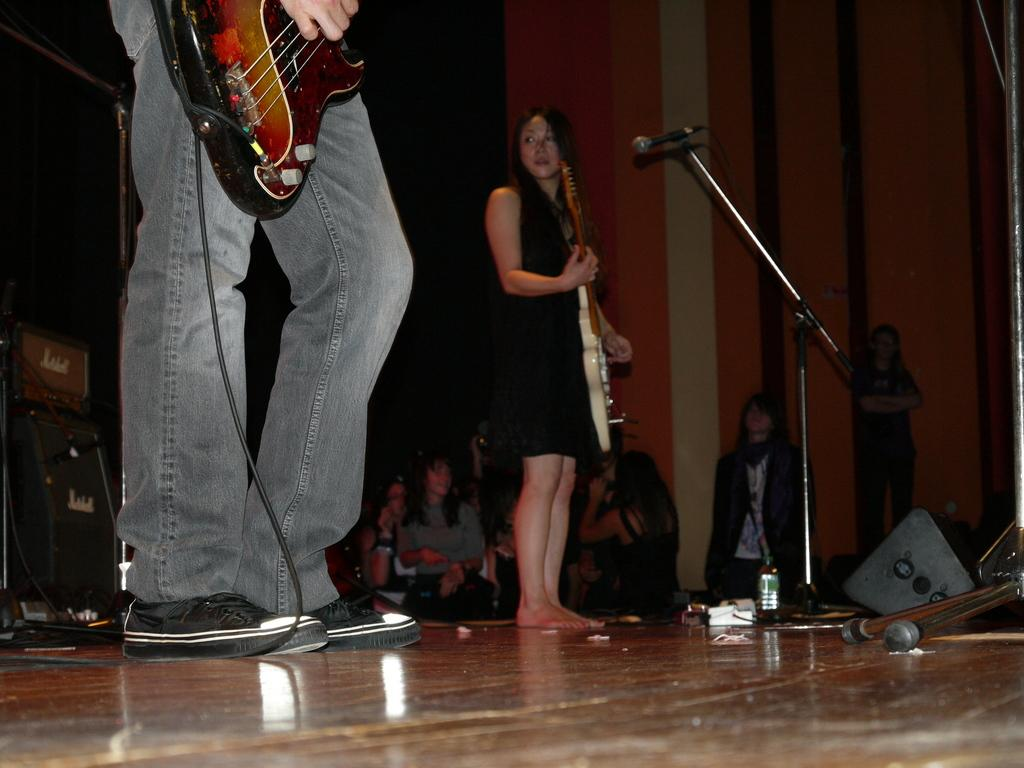How many people are in the image? There are people in the image. What are two of the people holding? Two people are holding guitars. What object is in front of one of the people? There is a microphone in front of one of the people. How does the earthquake affect the yard in the image? There is no earthquake or yard present in the image. What is the moon doing in the image? There is no moon visible in the image. 